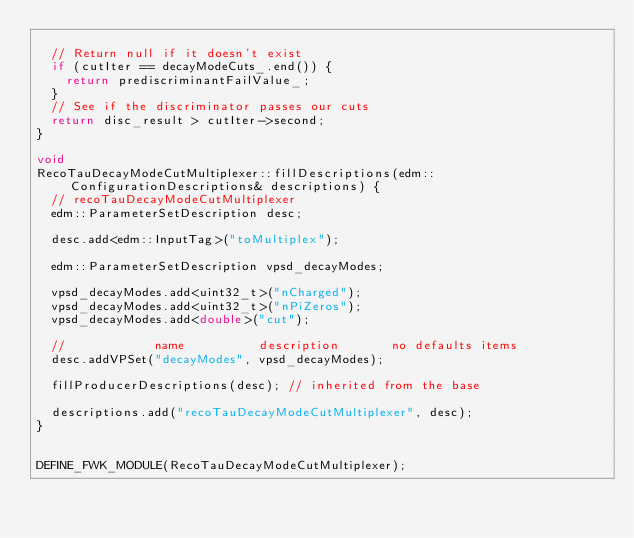<code> <loc_0><loc_0><loc_500><loc_500><_C++_>
  // Return null if it doesn't exist
  if (cutIter == decayModeCuts_.end()) {
    return prediscriminantFailValue_;
  }
  // See if the discriminator passes our cuts
  return disc_result > cutIter->second;
}

void
RecoTauDecayModeCutMultiplexer::fillDescriptions(edm::ConfigurationDescriptions& descriptions) {
  // recoTauDecayModeCutMultiplexer
  edm::ParameterSetDescription desc;

  desc.add<edm::InputTag>("toMultiplex");

  edm::ParameterSetDescription vpsd_decayModes;

  vpsd_decayModes.add<uint32_t>("nCharged");
  vpsd_decayModes.add<uint32_t>("nPiZeros");
  vpsd_decayModes.add<double>("cut");

  //            name          description       no defaults items
  desc.addVPSet("decayModes", vpsd_decayModes);

  fillProducerDescriptions(desc); // inherited from the base

  descriptions.add("recoTauDecayModeCutMultiplexer", desc);
}


DEFINE_FWK_MODULE(RecoTauDecayModeCutMultiplexer);
</code> 